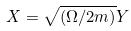<formula> <loc_0><loc_0><loc_500><loc_500>X = \sqrt { ( \Omega / 2 m ) } Y</formula> 